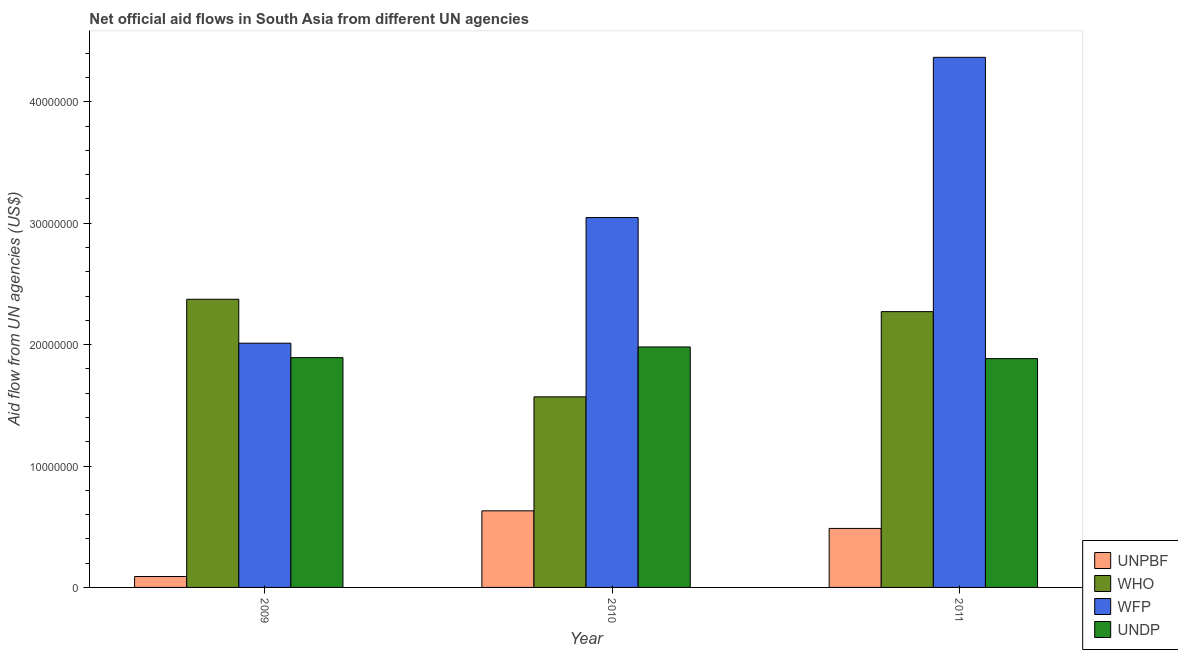How many groups of bars are there?
Provide a succinct answer. 3. How many bars are there on the 2nd tick from the left?
Keep it short and to the point. 4. What is the label of the 1st group of bars from the left?
Provide a short and direct response. 2009. In how many cases, is the number of bars for a given year not equal to the number of legend labels?
Your answer should be compact. 0. What is the amount of aid given by wfp in 2010?
Your answer should be very brief. 3.05e+07. Across all years, what is the maximum amount of aid given by unpbf?
Give a very brief answer. 6.31e+06. Across all years, what is the minimum amount of aid given by who?
Your answer should be compact. 1.57e+07. In which year was the amount of aid given by wfp maximum?
Your answer should be compact. 2011. What is the total amount of aid given by unpbf in the graph?
Give a very brief answer. 1.21e+07. What is the difference between the amount of aid given by undp in 2009 and that in 2011?
Your answer should be compact. 8.00e+04. What is the difference between the amount of aid given by undp in 2010 and the amount of aid given by unpbf in 2011?
Provide a short and direct response. 9.60e+05. What is the average amount of aid given by who per year?
Your answer should be very brief. 2.07e+07. In the year 2010, what is the difference between the amount of aid given by unpbf and amount of aid given by who?
Offer a terse response. 0. What is the ratio of the amount of aid given by undp in 2010 to that in 2011?
Give a very brief answer. 1.05. What is the difference between the highest and the second highest amount of aid given by undp?
Your answer should be very brief. 8.80e+05. What is the difference between the highest and the lowest amount of aid given by unpbf?
Ensure brevity in your answer.  5.41e+06. Is the sum of the amount of aid given by unpbf in 2010 and 2011 greater than the maximum amount of aid given by wfp across all years?
Make the answer very short. Yes. Is it the case that in every year, the sum of the amount of aid given by wfp and amount of aid given by unpbf is greater than the sum of amount of aid given by who and amount of aid given by undp?
Keep it short and to the point. No. What does the 2nd bar from the left in 2009 represents?
Offer a very short reply. WHO. What does the 1st bar from the right in 2009 represents?
Your answer should be compact. UNDP. Is it the case that in every year, the sum of the amount of aid given by unpbf and amount of aid given by who is greater than the amount of aid given by wfp?
Your response must be concise. No. How many bars are there?
Offer a terse response. 12. How many years are there in the graph?
Offer a very short reply. 3. Does the graph contain any zero values?
Offer a very short reply. No. Does the graph contain grids?
Make the answer very short. No. Where does the legend appear in the graph?
Give a very brief answer. Bottom right. How are the legend labels stacked?
Your response must be concise. Vertical. What is the title of the graph?
Your answer should be compact. Net official aid flows in South Asia from different UN agencies. What is the label or title of the X-axis?
Provide a short and direct response. Year. What is the label or title of the Y-axis?
Your response must be concise. Aid flow from UN agencies (US$). What is the Aid flow from UN agencies (US$) of WHO in 2009?
Give a very brief answer. 2.37e+07. What is the Aid flow from UN agencies (US$) in WFP in 2009?
Ensure brevity in your answer.  2.01e+07. What is the Aid flow from UN agencies (US$) of UNDP in 2009?
Keep it short and to the point. 1.89e+07. What is the Aid flow from UN agencies (US$) in UNPBF in 2010?
Your answer should be very brief. 6.31e+06. What is the Aid flow from UN agencies (US$) of WHO in 2010?
Ensure brevity in your answer.  1.57e+07. What is the Aid flow from UN agencies (US$) of WFP in 2010?
Your response must be concise. 3.05e+07. What is the Aid flow from UN agencies (US$) of UNDP in 2010?
Offer a terse response. 1.98e+07. What is the Aid flow from UN agencies (US$) in UNPBF in 2011?
Provide a succinct answer. 4.86e+06. What is the Aid flow from UN agencies (US$) in WHO in 2011?
Offer a very short reply. 2.27e+07. What is the Aid flow from UN agencies (US$) in WFP in 2011?
Your answer should be compact. 4.37e+07. What is the Aid flow from UN agencies (US$) of UNDP in 2011?
Give a very brief answer. 1.88e+07. Across all years, what is the maximum Aid flow from UN agencies (US$) of UNPBF?
Your response must be concise. 6.31e+06. Across all years, what is the maximum Aid flow from UN agencies (US$) in WHO?
Your response must be concise. 2.37e+07. Across all years, what is the maximum Aid flow from UN agencies (US$) of WFP?
Your response must be concise. 4.37e+07. Across all years, what is the maximum Aid flow from UN agencies (US$) in UNDP?
Keep it short and to the point. 1.98e+07. Across all years, what is the minimum Aid flow from UN agencies (US$) of UNPBF?
Provide a succinct answer. 9.00e+05. Across all years, what is the minimum Aid flow from UN agencies (US$) in WHO?
Give a very brief answer. 1.57e+07. Across all years, what is the minimum Aid flow from UN agencies (US$) in WFP?
Provide a short and direct response. 2.01e+07. Across all years, what is the minimum Aid flow from UN agencies (US$) of UNDP?
Provide a short and direct response. 1.88e+07. What is the total Aid flow from UN agencies (US$) of UNPBF in the graph?
Give a very brief answer. 1.21e+07. What is the total Aid flow from UN agencies (US$) in WHO in the graph?
Your response must be concise. 6.22e+07. What is the total Aid flow from UN agencies (US$) of WFP in the graph?
Provide a succinct answer. 9.43e+07. What is the total Aid flow from UN agencies (US$) in UNDP in the graph?
Provide a short and direct response. 5.76e+07. What is the difference between the Aid flow from UN agencies (US$) of UNPBF in 2009 and that in 2010?
Provide a succinct answer. -5.41e+06. What is the difference between the Aid flow from UN agencies (US$) of WHO in 2009 and that in 2010?
Offer a very short reply. 8.04e+06. What is the difference between the Aid flow from UN agencies (US$) of WFP in 2009 and that in 2010?
Give a very brief answer. -1.04e+07. What is the difference between the Aid flow from UN agencies (US$) in UNDP in 2009 and that in 2010?
Your answer should be very brief. -8.80e+05. What is the difference between the Aid flow from UN agencies (US$) in UNPBF in 2009 and that in 2011?
Your answer should be compact. -3.96e+06. What is the difference between the Aid flow from UN agencies (US$) of WHO in 2009 and that in 2011?
Ensure brevity in your answer.  1.02e+06. What is the difference between the Aid flow from UN agencies (US$) of WFP in 2009 and that in 2011?
Give a very brief answer. -2.36e+07. What is the difference between the Aid flow from UN agencies (US$) in UNPBF in 2010 and that in 2011?
Ensure brevity in your answer.  1.45e+06. What is the difference between the Aid flow from UN agencies (US$) in WHO in 2010 and that in 2011?
Your answer should be very brief. -7.02e+06. What is the difference between the Aid flow from UN agencies (US$) in WFP in 2010 and that in 2011?
Your response must be concise. -1.32e+07. What is the difference between the Aid flow from UN agencies (US$) in UNDP in 2010 and that in 2011?
Your answer should be compact. 9.60e+05. What is the difference between the Aid flow from UN agencies (US$) of UNPBF in 2009 and the Aid flow from UN agencies (US$) of WHO in 2010?
Offer a terse response. -1.48e+07. What is the difference between the Aid flow from UN agencies (US$) in UNPBF in 2009 and the Aid flow from UN agencies (US$) in WFP in 2010?
Your response must be concise. -2.96e+07. What is the difference between the Aid flow from UN agencies (US$) in UNPBF in 2009 and the Aid flow from UN agencies (US$) in UNDP in 2010?
Offer a terse response. -1.89e+07. What is the difference between the Aid flow from UN agencies (US$) in WHO in 2009 and the Aid flow from UN agencies (US$) in WFP in 2010?
Offer a terse response. -6.73e+06. What is the difference between the Aid flow from UN agencies (US$) in WHO in 2009 and the Aid flow from UN agencies (US$) in UNDP in 2010?
Your response must be concise. 3.93e+06. What is the difference between the Aid flow from UN agencies (US$) of WFP in 2009 and the Aid flow from UN agencies (US$) of UNDP in 2010?
Your answer should be compact. 3.10e+05. What is the difference between the Aid flow from UN agencies (US$) of UNPBF in 2009 and the Aid flow from UN agencies (US$) of WHO in 2011?
Give a very brief answer. -2.18e+07. What is the difference between the Aid flow from UN agencies (US$) in UNPBF in 2009 and the Aid flow from UN agencies (US$) in WFP in 2011?
Your response must be concise. -4.28e+07. What is the difference between the Aid flow from UN agencies (US$) of UNPBF in 2009 and the Aid flow from UN agencies (US$) of UNDP in 2011?
Ensure brevity in your answer.  -1.80e+07. What is the difference between the Aid flow from UN agencies (US$) of WHO in 2009 and the Aid flow from UN agencies (US$) of WFP in 2011?
Keep it short and to the point. -1.99e+07. What is the difference between the Aid flow from UN agencies (US$) of WHO in 2009 and the Aid flow from UN agencies (US$) of UNDP in 2011?
Offer a very short reply. 4.89e+06. What is the difference between the Aid flow from UN agencies (US$) of WFP in 2009 and the Aid flow from UN agencies (US$) of UNDP in 2011?
Make the answer very short. 1.27e+06. What is the difference between the Aid flow from UN agencies (US$) in UNPBF in 2010 and the Aid flow from UN agencies (US$) in WHO in 2011?
Provide a short and direct response. -1.64e+07. What is the difference between the Aid flow from UN agencies (US$) in UNPBF in 2010 and the Aid flow from UN agencies (US$) in WFP in 2011?
Provide a succinct answer. -3.74e+07. What is the difference between the Aid flow from UN agencies (US$) of UNPBF in 2010 and the Aid flow from UN agencies (US$) of UNDP in 2011?
Offer a very short reply. -1.25e+07. What is the difference between the Aid flow from UN agencies (US$) in WHO in 2010 and the Aid flow from UN agencies (US$) in WFP in 2011?
Offer a very short reply. -2.80e+07. What is the difference between the Aid flow from UN agencies (US$) in WHO in 2010 and the Aid flow from UN agencies (US$) in UNDP in 2011?
Offer a terse response. -3.15e+06. What is the difference between the Aid flow from UN agencies (US$) in WFP in 2010 and the Aid flow from UN agencies (US$) in UNDP in 2011?
Keep it short and to the point. 1.16e+07. What is the average Aid flow from UN agencies (US$) of UNPBF per year?
Provide a succinct answer. 4.02e+06. What is the average Aid flow from UN agencies (US$) of WHO per year?
Offer a terse response. 2.07e+07. What is the average Aid flow from UN agencies (US$) of WFP per year?
Your response must be concise. 3.14e+07. What is the average Aid flow from UN agencies (US$) of UNDP per year?
Provide a succinct answer. 1.92e+07. In the year 2009, what is the difference between the Aid flow from UN agencies (US$) of UNPBF and Aid flow from UN agencies (US$) of WHO?
Ensure brevity in your answer.  -2.28e+07. In the year 2009, what is the difference between the Aid flow from UN agencies (US$) of UNPBF and Aid flow from UN agencies (US$) of WFP?
Provide a short and direct response. -1.92e+07. In the year 2009, what is the difference between the Aid flow from UN agencies (US$) of UNPBF and Aid flow from UN agencies (US$) of UNDP?
Your answer should be compact. -1.80e+07. In the year 2009, what is the difference between the Aid flow from UN agencies (US$) in WHO and Aid flow from UN agencies (US$) in WFP?
Your answer should be compact. 3.62e+06. In the year 2009, what is the difference between the Aid flow from UN agencies (US$) of WHO and Aid flow from UN agencies (US$) of UNDP?
Keep it short and to the point. 4.81e+06. In the year 2009, what is the difference between the Aid flow from UN agencies (US$) of WFP and Aid flow from UN agencies (US$) of UNDP?
Offer a terse response. 1.19e+06. In the year 2010, what is the difference between the Aid flow from UN agencies (US$) of UNPBF and Aid flow from UN agencies (US$) of WHO?
Offer a very short reply. -9.39e+06. In the year 2010, what is the difference between the Aid flow from UN agencies (US$) in UNPBF and Aid flow from UN agencies (US$) in WFP?
Your answer should be very brief. -2.42e+07. In the year 2010, what is the difference between the Aid flow from UN agencies (US$) of UNPBF and Aid flow from UN agencies (US$) of UNDP?
Your response must be concise. -1.35e+07. In the year 2010, what is the difference between the Aid flow from UN agencies (US$) of WHO and Aid flow from UN agencies (US$) of WFP?
Make the answer very short. -1.48e+07. In the year 2010, what is the difference between the Aid flow from UN agencies (US$) of WHO and Aid flow from UN agencies (US$) of UNDP?
Offer a very short reply. -4.11e+06. In the year 2010, what is the difference between the Aid flow from UN agencies (US$) in WFP and Aid flow from UN agencies (US$) in UNDP?
Make the answer very short. 1.07e+07. In the year 2011, what is the difference between the Aid flow from UN agencies (US$) of UNPBF and Aid flow from UN agencies (US$) of WHO?
Make the answer very short. -1.79e+07. In the year 2011, what is the difference between the Aid flow from UN agencies (US$) in UNPBF and Aid flow from UN agencies (US$) in WFP?
Provide a succinct answer. -3.88e+07. In the year 2011, what is the difference between the Aid flow from UN agencies (US$) of UNPBF and Aid flow from UN agencies (US$) of UNDP?
Provide a short and direct response. -1.40e+07. In the year 2011, what is the difference between the Aid flow from UN agencies (US$) of WHO and Aid flow from UN agencies (US$) of WFP?
Your answer should be compact. -2.10e+07. In the year 2011, what is the difference between the Aid flow from UN agencies (US$) of WHO and Aid flow from UN agencies (US$) of UNDP?
Make the answer very short. 3.87e+06. In the year 2011, what is the difference between the Aid flow from UN agencies (US$) of WFP and Aid flow from UN agencies (US$) of UNDP?
Offer a terse response. 2.48e+07. What is the ratio of the Aid flow from UN agencies (US$) of UNPBF in 2009 to that in 2010?
Keep it short and to the point. 0.14. What is the ratio of the Aid flow from UN agencies (US$) of WHO in 2009 to that in 2010?
Provide a succinct answer. 1.51. What is the ratio of the Aid flow from UN agencies (US$) in WFP in 2009 to that in 2010?
Provide a succinct answer. 0.66. What is the ratio of the Aid flow from UN agencies (US$) of UNDP in 2009 to that in 2010?
Make the answer very short. 0.96. What is the ratio of the Aid flow from UN agencies (US$) of UNPBF in 2009 to that in 2011?
Ensure brevity in your answer.  0.19. What is the ratio of the Aid flow from UN agencies (US$) of WHO in 2009 to that in 2011?
Offer a very short reply. 1.04. What is the ratio of the Aid flow from UN agencies (US$) in WFP in 2009 to that in 2011?
Make the answer very short. 0.46. What is the ratio of the Aid flow from UN agencies (US$) in UNPBF in 2010 to that in 2011?
Give a very brief answer. 1.3. What is the ratio of the Aid flow from UN agencies (US$) in WHO in 2010 to that in 2011?
Keep it short and to the point. 0.69. What is the ratio of the Aid flow from UN agencies (US$) of WFP in 2010 to that in 2011?
Ensure brevity in your answer.  0.7. What is the ratio of the Aid flow from UN agencies (US$) of UNDP in 2010 to that in 2011?
Make the answer very short. 1.05. What is the difference between the highest and the second highest Aid flow from UN agencies (US$) of UNPBF?
Your response must be concise. 1.45e+06. What is the difference between the highest and the second highest Aid flow from UN agencies (US$) of WHO?
Your answer should be compact. 1.02e+06. What is the difference between the highest and the second highest Aid flow from UN agencies (US$) in WFP?
Provide a short and direct response. 1.32e+07. What is the difference between the highest and the second highest Aid flow from UN agencies (US$) of UNDP?
Give a very brief answer. 8.80e+05. What is the difference between the highest and the lowest Aid flow from UN agencies (US$) of UNPBF?
Provide a succinct answer. 5.41e+06. What is the difference between the highest and the lowest Aid flow from UN agencies (US$) in WHO?
Make the answer very short. 8.04e+06. What is the difference between the highest and the lowest Aid flow from UN agencies (US$) in WFP?
Provide a succinct answer. 2.36e+07. What is the difference between the highest and the lowest Aid flow from UN agencies (US$) of UNDP?
Give a very brief answer. 9.60e+05. 